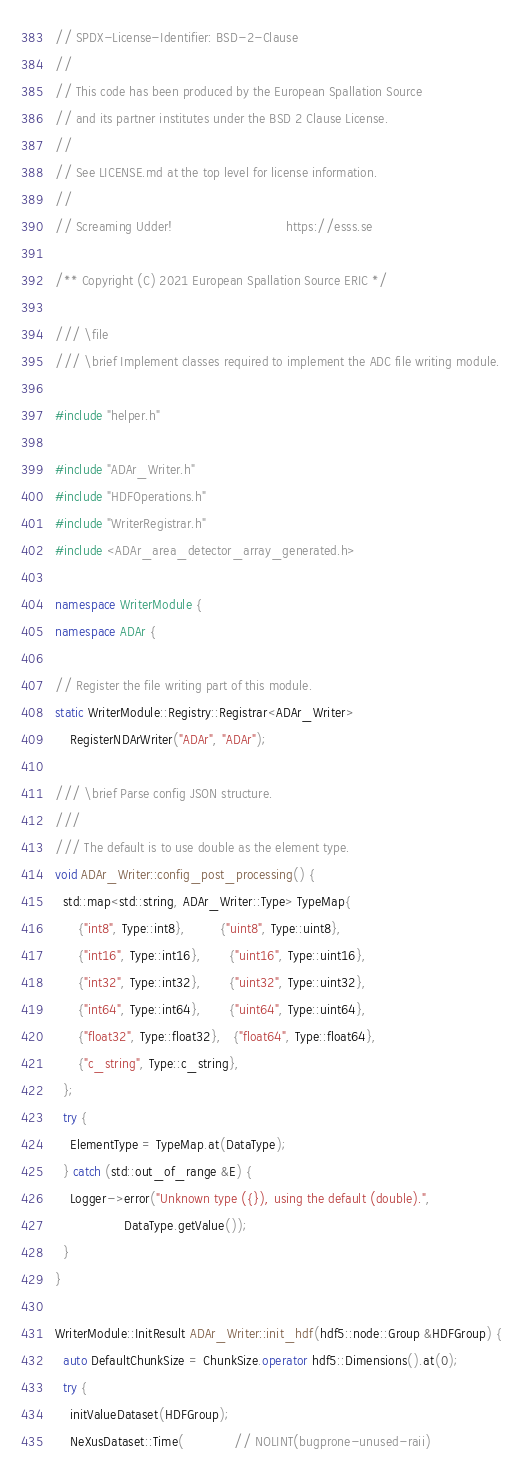<code> <loc_0><loc_0><loc_500><loc_500><_C++_>// SPDX-License-Identifier: BSD-2-Clause
//
// This code has been produced by the European Spallation Source
// and its partner institutes under the BSD 2 Clause License.
//
// See LICENSE.md at the top level for license information.
//
// Screaming Udder!                              https://esss.se

/** Copyright (C) 2021 European Spallation Source ERIC */

/// \file
/// \brief Implement classes required to implement the ADC file writing module.

#include "helper.h"

#include "ADAr_Writer.h"
#include "HDFOperations.h"
#include "WriterRegistrar.h"
#include <ADAr_area_detector_array_generated.h>

namespace WriterModule {
namespace ADAr {

// Register the file writing part of this module.
static WriterModule::Registry::Registrar<ADAr_Writer>
    RegisterNDArWriter("ADAr", "ADAr");

/// \brief Parse config JSON structure.
///
/// The default is to use double as the element type.
void ADAr_Writer::config_post_processing() {
  std::map<std::string, ADAr_Writer::Type> TypeMap{
      {"int8", Type::int8},         {"uint8", Type::uint8},
      {"int16", Type::int16},       {"uint16", Type::uint16},
      {"int32", Type::int32},       {"uint32", Type::uint32},
      {"int64", Type::int64},       {"uint64", Type::uint64},
      {"float32", Type::float32},   {"float64", Type::float64},
      {"c_string", Type::c_string},
  };
  try {
    ElementType = TypeMap.at(DataType);
  } catch (std::out_of_range &E) {
    Logger->error("Unknown type ({}), using the default (double).",
                  DataType.getValue());
  }
}

WriterModule::InitResult ADAr_Writer::init_hdf(hdf5::node::Group &HDFGroup) {
  auto DefaultChunkSize = ChunkSize.operator hdf5::Dimensions().at(0);
  try {
    initValueDataset(HDFGroup);
    NeXusDataset::Time(             // NOLINT(bugprone-unused-raii)</code> 